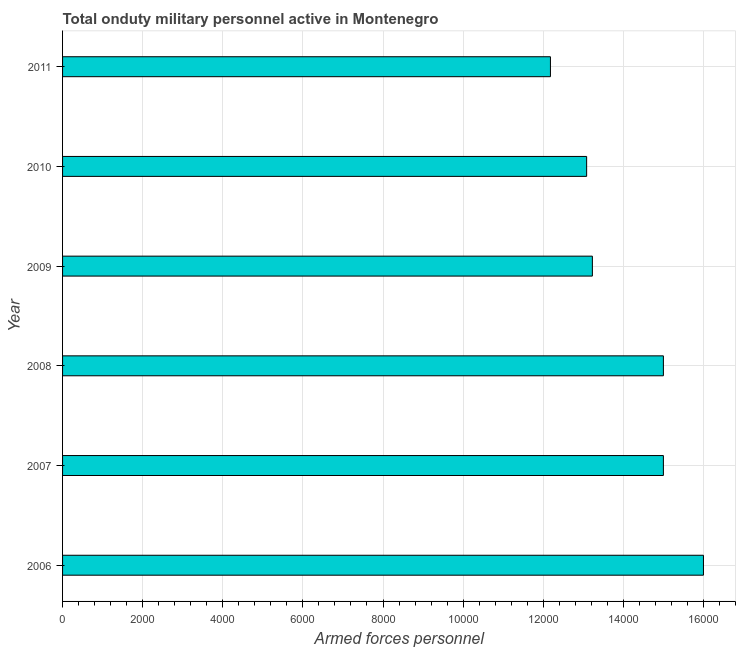What is the title of the graph?
Keep it short and to the point. Total onduty military personnel active in Montenegro. What is the label or title of the X-axis?
Provide a short and direct response. Armed forces personnel. What is the label or title of the Y-axis?
Your response must be concise. Year. What is the number of armed forces personnel in 2007?
Your response must be concise. 1.50e+04. Across all years, what is the maximum number of armed forces personnel?
Make the answer very short. 1.60e+04. Across all years, what is the minimum number of armed forces personnel?
Offer a terse response. 1.22e+04. What is the sum of the number of armed forces personnel?
Keep it short and to the point. 8.45e+04. What is the difference between the number of armed forces personnel in 2009 and 2010?
Make the answer very short. 143. What is the average number of armed forces personnel per year?
Keep it short and to the point. 1.41e+04. What is the median number of armed forces personnel?
Your answer should be very brief. 1.41e+04. In how many years, is the number of armed forces personnel greater than 800 ?
Provide a succinct answer. 6. What is the ratio of the number of armed forces personnel in 2010 to that in 2011?
Keep it short and to the point. 1.07. Is the difference between the number of armed forces personnel in 2006 and 2007 greater than the difference between any two years?
Provide a short and direct response. No. Is the sum of the number of armed forces personnel in 2008 and 2011 greater than the maximum number of armed forces personnel across all years?
Keep it short and to the point. Yes. What is the difference between the highest and the lowest number of armed forces personnel?
Give a very brief answer. 3820. In how many years, is the number of armed forces personnel greater than the average number of armed forces personnel taken over all years?
Make the answer very short. 3. How many bars are there?
Your answer should be very brief. 6. How many years are there in the graph?
Offer a very short reply. 6. What is the difference between two consecutive major ticks on the X-axis?
Keep it short and to the point. 2000. Are the values on the major ticks of X-axis written in scientific E-notation?
Keep it short and to the point. No. What is the Armed forces personnel in 2006?
Ensure brevity in your answer.  1.60e+04. What is the Armed forces personnel of 2007?
Make the answer very short. 1.50e+04. What is the Armed forces personnel of 2008?
Provide a short and direct response. 1.50e+04. What is the Armed forces personnel in 2009?
Provide a short and direct response. 1.32e+04. What is the Armed forces personnel in 2010?
Make the answer very short. 1.31e+04. What is the Armed forces personnel in 2011?
Keep it short and to the point. 1.22e+04. What is the difference between the Armed forces personnel in 2006 and 2007?
Your answer should be very brief. 1000. What is the difference between the Armed forces personnel in 2006 and 2008?
Offer a very short reply. 1000. What is the difference between the Armed forces personnel in 2006 and 2009?
Keep it short and to the point. 2773. What is the difference between the Armed forces personnel in 2006 and 2010?
Make the answer very short. 2916. What is the difference between the Armed forces personnel in 2006 and 2011?
Your answer should be very brief. 3820. What is the difference between the Armed forces personnel in 2007 and 2009?
Offer a terse response. 1773. What is the difference between the Armed forces personnel in 2007 and 2010?
Offer a terse response. 1916. What is the difference between the Armed forces personnel in 2007 and 2011?
Make the answer very short. 2820. What is the difference between the Armed forces personnel in 2008 and 2009?
Provide a succinct answer. 1773. What is the difference between the Armed forces personnel in 2008 and 2010?
Keep it short and to the point. 1916. What is the difference between the Armed forces personnel in 2008 and 2011?
Your answer should be very brief. 2820. What is the difference between the Armed forces personnel in 2009 and 2010?
Your response must be concise. 143. What is the difference between the Armed forces personnel in 2009 and 2011?
Provide a short and direct response. 1047. What is the difference between the Armed forces personnel in 2010 and 2011?
Your answer should be compact. 904. What is the ratio of the Armed forces personnel in 2006 to that in 2007?
Offer a terse response. 1.07. What is the ratio of the Armed forces personnel in 2006 to that in 2008?
Offer a terse response. 1.07. What is the ratio of the Armed forces personnel in 2006 to that in 2009?
Provide a succinct answer. 1.21. What is the ratio of the Armed forces personnel in 2006 to that in 2010?
Provide a short and direct response. 1.22. What is the ratio of the Armed forces personnel in 2006 to that in 2011?
Keep it short and to the point. 1.31. What is the ratio of the Armed forces personnel in 2007 to that in 2008?
Offer a terse response. 1. What is the ratio of the Armed forces personnel in 2007 to that in 2009?
Give a very brief answer. 1.13. What is the ratio of the Armed forces personnel in 2007 to that in 2010?
Your answer should be very brief. 1.15. What is the ratio of the Armed forces personnel in 2007 to that in 2011?
Keep it short and to the point. 1.23. What is the ratio of the Armed forces personnel in 2008 to that in 2009?
Offer a terse response. 1.13. What is the ratio of the Armed forces personnel in 2008 to that in 2010?
Offer a terse response. 1.15. What is the ratio of the Armed forces personnel in 2008 to that in 2011?
Provide a succinct answer. 1.23. What is the ratio of the Armed forces personnel in 2009 to that in 2011?
Your answer should be very brief. 1.09. What is the ratio of the Armed forces personnel in 2010 to that in 2011?
Ensure brevity in your answer.  1.07. 